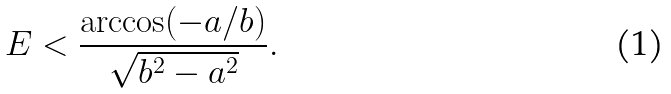Convert formula to latex. <formula><loc_0><loc_0><loc_500><loc_500>E < \frac { \arccos ( - a / b ) } { \sqrt { b ^ { 2 } - a ^ { 2 } } } .</formula> 